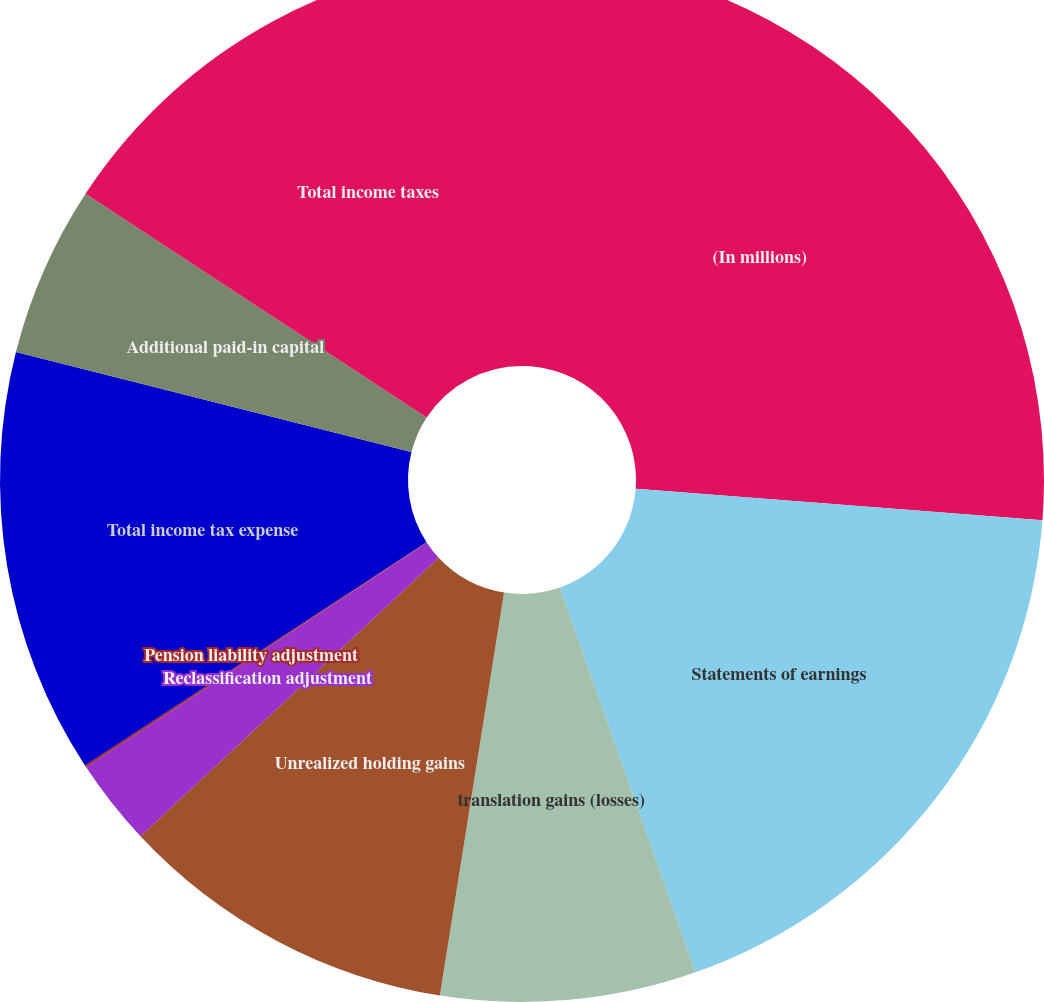<chart> <loc_0><loc_0><loc_500><loc_500><pie_chart><fcel>(In millions)<fcel>Statements of earnings<fcel>translation gains (losses)<fcel>Unrealized holding gains<fcel>Reclassification adjustment<fcel>Pension liability adjustment<fcel>Total income tax expense<fcel>Additional paid-in capital<fcel>Total income taxes<nl><fcel>26.23%<fcel>18.38%<fcel>7.91%<fcel>10.53%<fcel>2.68%<fcel>0.07%<fcel>13.15%<fcel>5.3%<fcel>15.76%<nl></chart> 